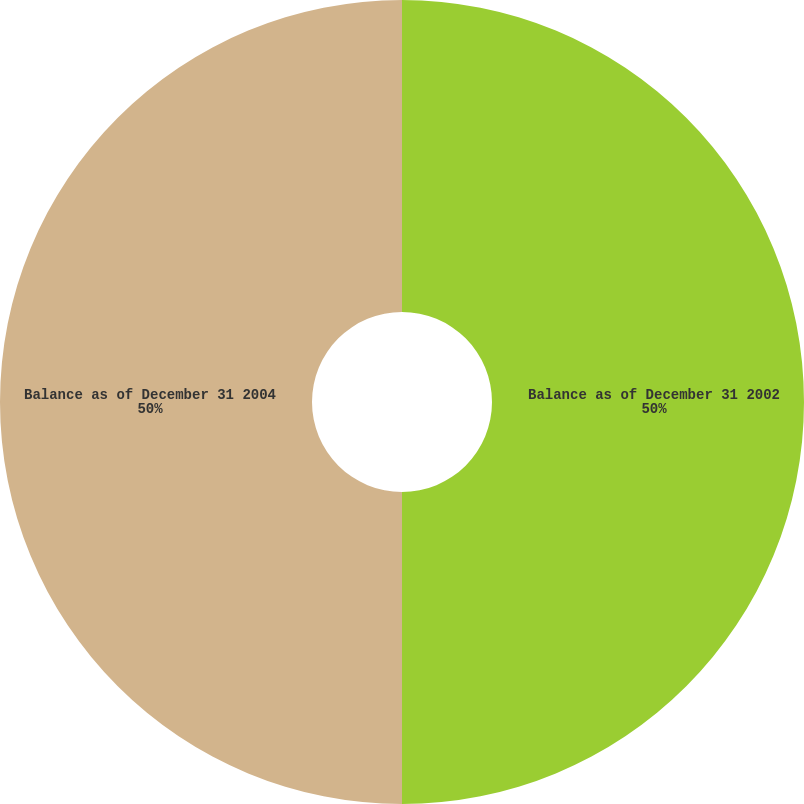Convert chart. <chart><loc_0><loc_0><loc_500><loc_500><pie_chart><fcel>Balance as of December 31 2002<fcel>Balance as of December 31 2004<nl><fcel>50.0%<fcel>50.0%<nl></chart> 